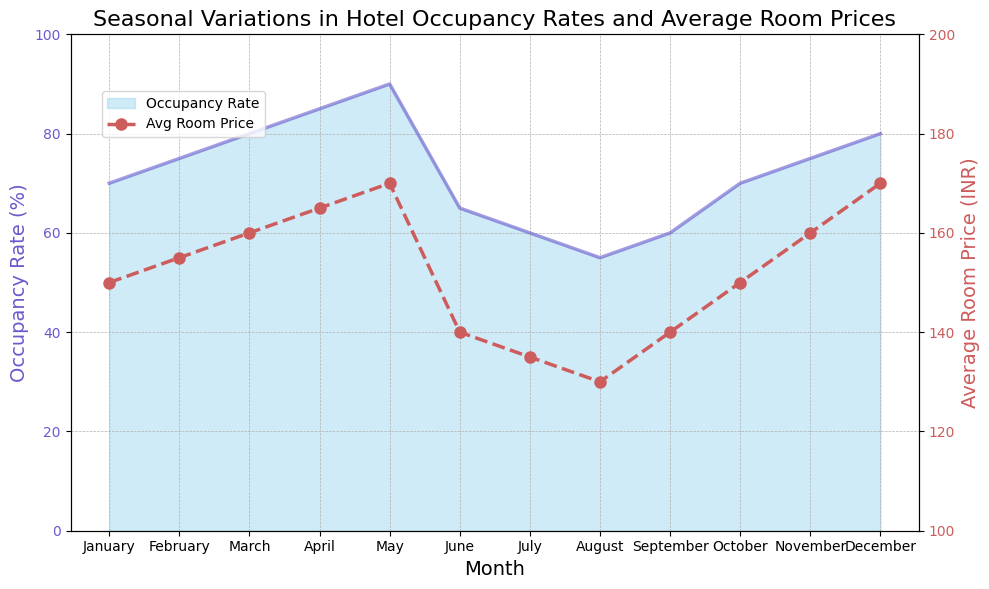Which month has the highest occupancy rate? The highest point on the occupancy rate line is in May, which reaches 90%.
Answer: May How does the average room price in December compare to that in June? The average room price in December is 170 INR, while in June it's 140 INR.
Answer: Higher During which month is the difference between occupancy rate and average room price the smallest? Comparing the values for each month, April has an occupancy rate of 85% and an average room price of 165 INR, making the difference 80. This is the smallest difference when compared to other months.
Answer: April What is the trend of occupancy rates from January to May? Starting from January at 70%, the occupancy rate increases consistently each month until May, where it peaks at 90%.
Answer: Increasing In which months are the occupancy rates below 70% and how do their average room prices compare? Occupancy rates are below 70% in June (65%), July (60%), and August (55%). Their average room prices are 140 INR, 135 INR, and 130 INR respectively, which are lower than in other months.
Answer: June, July, August; lower Compare the occupancy rates of July and October. July has an occupancy rate of 60%, while October has an occupancy rate of 70%.
Answer: October is higher What is the average occupancy rate for the months with the highest and lowest average room prices? The month with the highest average room price is May (170 INR) which has an occupancy rate of 90%. The month with the lowest average room price is August (130 INR) with an occupancy rate of 55%. So the average occupancy rate is (90 + 55) / 2 = 72.5%.
Answer: 72.5% Which month sees a significant drop in occupancy rate compared to its previous month? The most significant drop in occupancy rate is from May (90%) to June (65%), a decrease of 25%.
Answer: June What is the visual representation color of the average room price line? The average room price line is represented in a dashed style with a red color.
Answer: Red Between October and December, how does the occupancy rate change and is it associated with a similar change in average room price? From October (70%) to December (80%), the occupancy rate increases by 10%. The average room price also rises from 150 INR to 170 INR. Both have an upward trend.
Answer: Both increase 